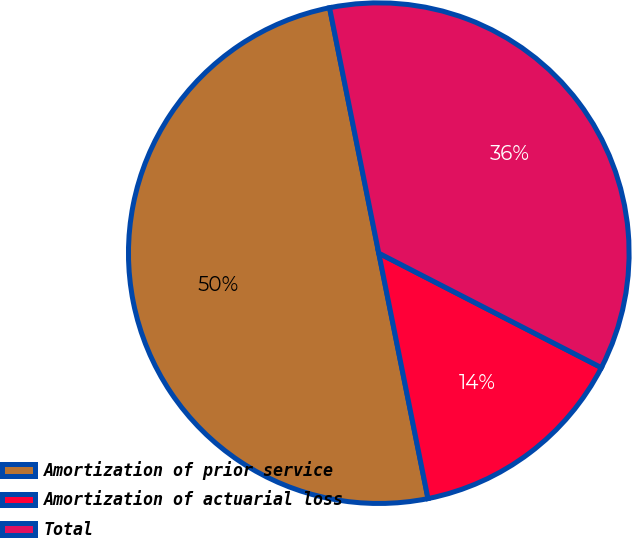Convert chart. <chart><loc_0><loc_0><loc_500><loc_500><pie_chart><fcel>Amortization of prior service<fcel>Amortization of actuarial loss<fcel>Total<nl><fcel>50.0%<fcel>14.29%<fcel>35.71%<nl></chart> 